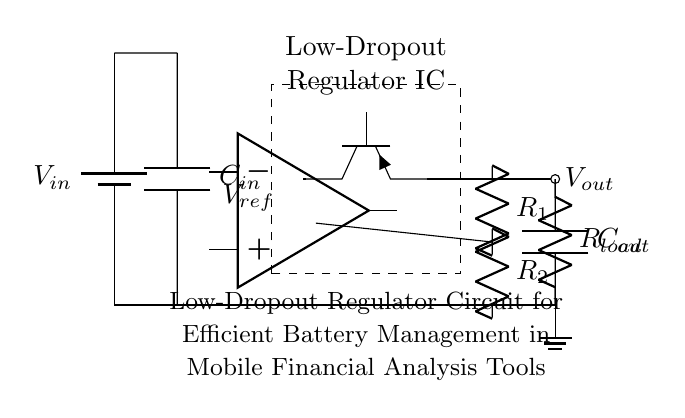What is the input voltage of the circuit? The input voltage is labeled as \( V_{in} \) on the battery symbol, which indicates the voltage supplied to the circuit.
Answer: \( V_{in} \) What is the purpose of the capacitor \( C_{in} \)? The capacitor \( C_{in} \) is used to filter and stabilize the input voltage coming from the battery, smoothing out any fluctuations.
Answer: Filter What kind of transistor is used in this circuit? The circuit uses a PNP transistor, indicated by the symbol \( Tpnp \) next to the pass transistor.
Answer: PNP What are the resistances in the feedback network? The feedback network consists of two resistors labeled \( R_1 \) and \( R_2 \), which set the output voltage based on the feedback to the error amplifier.
Answer: \( R_1, R_2 \) How does the error amplifier function in this circuit? The error amplifier compares the reference voltage \( V_{ref} \) to the output voltage and adjusts the pass transistor accordingly to maintain the desired output voltage level.
Answer: Regulation What is the function of the output capacitor \( C_{out} \)? The output capacitor \( C_{out} \) improves load transient response and filters the output voltage, ensuring it remains stable under varying load conditions.
Answer: Stabilization What is the load in this circuit? The load is represented by the resistor labeled \( R_{load} \), which consumes power from the regulated output voltage.
Answer: \( R_{load} \) 